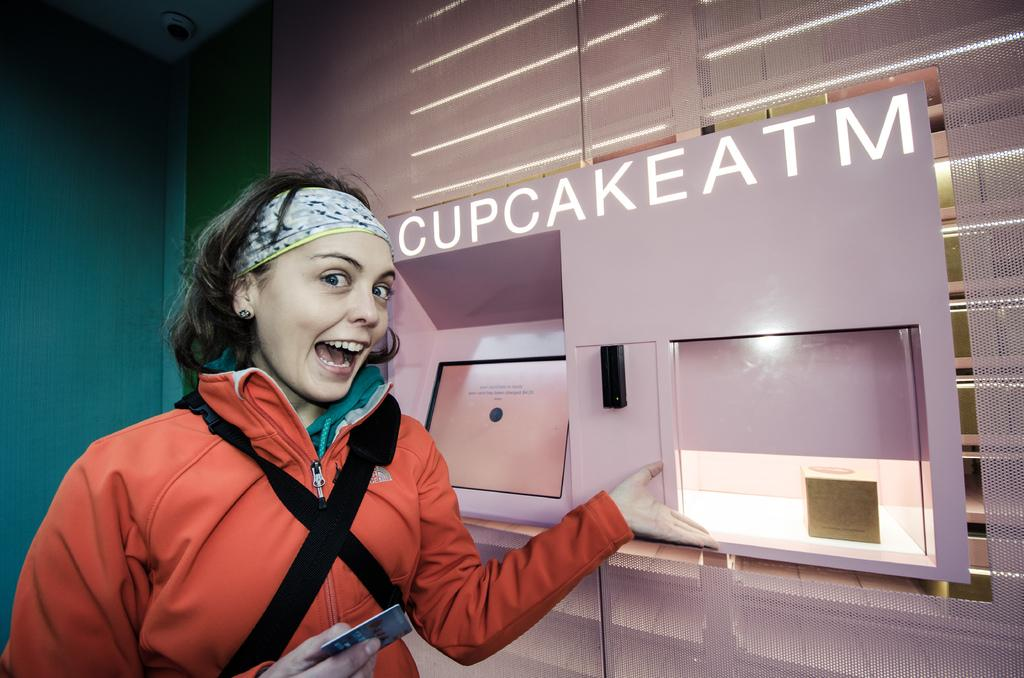<image>
Write a terse but informative summary of the picture. A girl is getting a cupcake out of the cupcake ATM. 